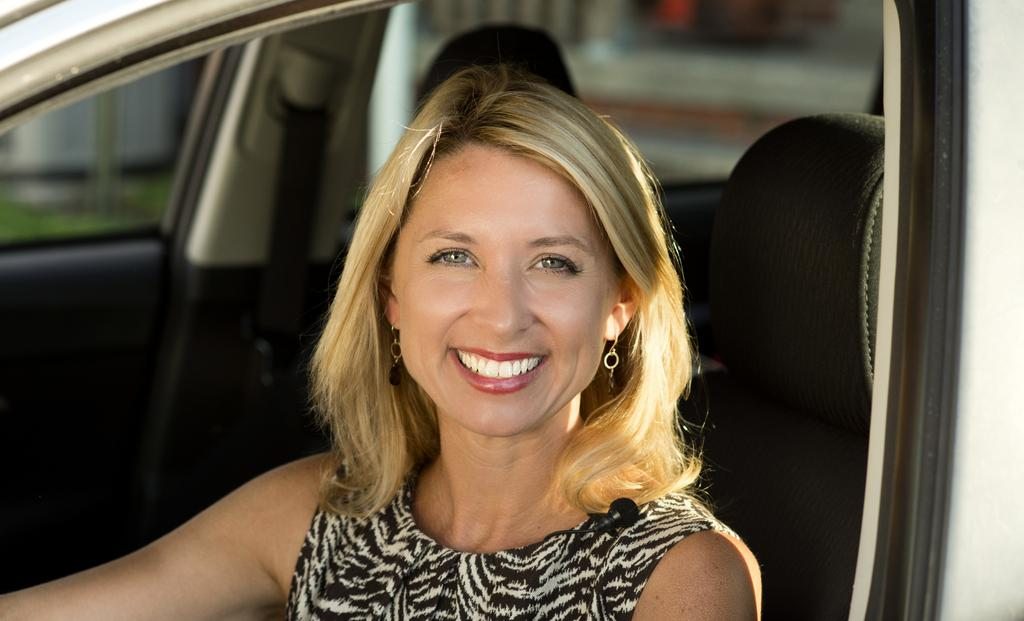Who is present in the image? There is a woman in the image. What is the woman doing in the image? The woman is sitting inside a vehicle. What is the woman's expression in the image? The woman is smiling. What type of fork is the woman using to write on the chalkboard in the image? There is no fork or chalkboard present in the image. 